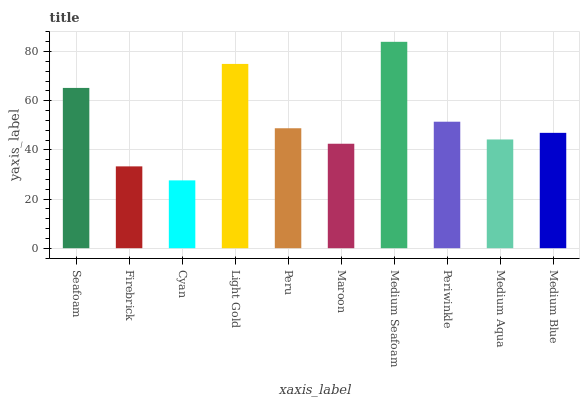Is Cyan the minimum?
Answer yes or no. Yes. Is Medium Seafoam the maximum?
Answer yes or no. Yes. Is Firebrick the minimum?
Answer yes or no. No. Is Firebrick the maximum?
Answer yes or no. No. Is Seafoam greater than Firebrick?
Answer yes or no. Yes. Is Firebrick less than Seafoam?
Answer yes or no. Yes. Is Firebrick greater than Seafoam?
Answer yes or no. No. Is Seafoam less than Firebrick?
Answer yes or no. No. Is Peru the high median?
Answer yes or no. Yes. Is Medium Blue the low median?
Answer yes or no. Yes. Is Seafoam the high median?
Answer yes or no. No. Is Maroon the low median?
Answer yes or no. No. 